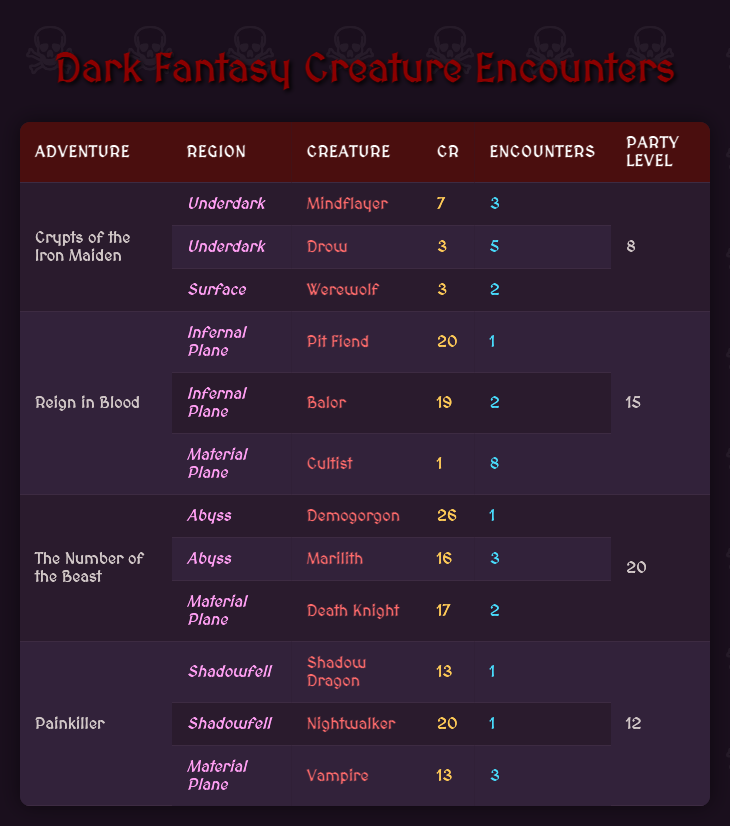What is the highest Challenge Rating among the creatures listed? The highest Challenge Rating can be found by looking at the CR column. Scanning through the values, I see that the highest CR is 26, associated with the creature Demogorgon in the adventure "The Number of the Beast."
Answer: 26 How many encounters involve vampires across all adventures? By examining the encounters, I see that vampires appear in the "Painkiller" adventure with 3 encounters. Therefore, the total count of vampire encounters is simply 3.
Answer: 3 Which adventure has the most encounters in total? To find the adventure with the most encounters, I will sum all encounters for each adventure. "Crypts of the Iron Maiden" has 10 encounters (3 + 5 + 2), "Reign in Blood" has 11 encounters (1 + 2 + 8), "The Number of the Beast" has 6 encounters (1 + 3 + 2), and "Painkiller" has 5 encounters (1 + 1 + 3). The highest total is 11 from "Reign in Blood."
Answer: Reign in Blood Is there a creature with a Challenge Rating of 1 in the table? I will check the CR column for the value of 1. The creature Cultist from the adventure "Reign in Blood" has a CR of 1. Therefore, the answer is yes.
Answer: Yes Which region contains the most encounters for creatures with CR 20? I need to look for all creatures with a CR of 20 and note their regions. The Nightwalker and the Pit Fiend both have a CR of 20. The Nightwalker is found in the Shadowfell, and the Pit Fiend is located in the Infernal Plane. Each region has 1 encounter for their respective creatures, making a total of 1 encounter each. Therefore, there is no region with more than 1 encounter for CR 20 creatures.
Answer: Neither region has more than 1 encounter 